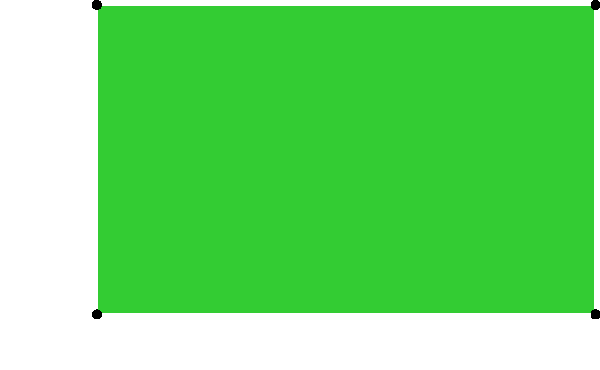Hey Gavin, remember that Gaelic football pitch we played on last weekend? I'm trying to figure out its area. The pitch was rectangular, 145 meters long and 90 meters wide. Can you help me calculate the total area of the pitch in square meters? To find the area of a rectangular Gaelic football pitch, we need to multiply its length by its width. Here's how we can do it step by step:

1. Identify the length and width of the pitch:
   Length = 145 meters
   Width = 90 meters

2. Use the formula for the area of a rectangle:
   Area = Length × Width

3. Plug in the values:
   Area = 145 m × 90 m

4. Perform the multiplication:
   Area = 13,050 m²

Therefore, the total area of the Gaelic football pitch is 13,050 square meters.
Answer: 13,050 m² 